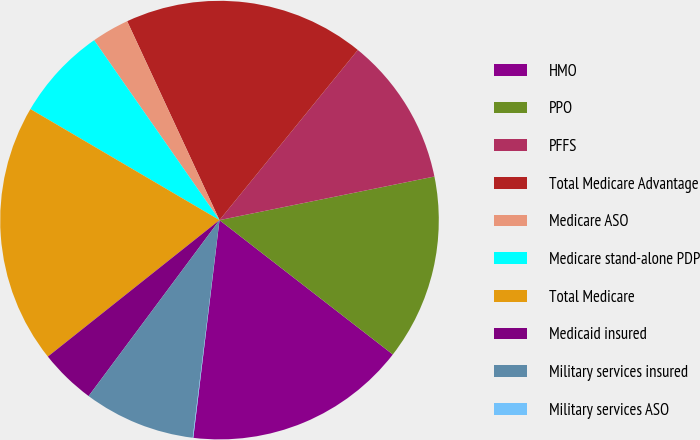<chart> <loc_0><loc_0><loc_500><loc_500><pie_chart><fcel>HMO<fcel>PPO<fcel>PFFS<fcel>Total Medicare Advantage<fcel>Medicare ASO<fcel>Medicare stand-alone PDP<fcel>Total Medicare<fcel>Medicaid insured<fcel>Military services insured<fcel>Military services ASO<nl><fcel>16.41%<fcel>13.68%<fcel>10.95%<fcel>17.78%<fcel>2.77%<fcel>6.86%<fcel>19.14%<fcel>4.13%<fcel>8.23%<fcel>0.04%<nl></chart> 